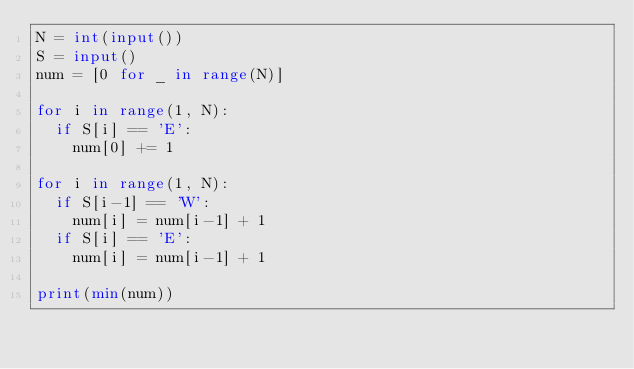<code> <loc_0><loc_0><loc_500><loc_500><_Python_>N = int(input())
S = input()
num = [0 for _ in range(N)]

for i in range(1, N):
  if S[i] == 'E':
    num[0] += 1

for i in range(1, N):
  if S[i-1] == 'W':
    num[i] = num[i-1] + 1
  if S[i] == 'E':
    num[i] = num[i-1] + 1
    
print(min(num))</code> 